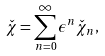<formula> <loc_0><loc_0><loc_500><loc_500>\check { \chi } = \sum _ { n = 0 } ^ { \infty } { \epsilon ^ { n } \check { \chi } _ { n } } ,</formula> 